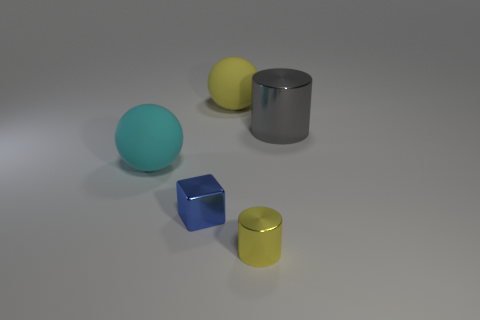The thing that is on the left side of the big yellow object and behind the cube is made of what material?
Your answer should be compact. Rubber. There is a big metallic thing behind the yellow metal cylinder; what is its shape?
Your response must be concise. Cylinder. What shape is the tiny metallic thing on the left side of the rubber sphere that is behind the gray cylinder?
Your response must be concise. Cube. Is there a large yellow object of the same shape as the small yellow object?
Offer a terse response. No. There is a metallic object that is the same size as the yellow shiny cylinder; what shape is it?
Offer a terse response. Cube. There is a shiny cylinder in front of the large rubber sphere that is on the left side of the large yellow matte ball; is there a yellow object on the left side of it?
Provide a succinct answer. Yes. Is there a blue object of the same size as the blue metal cube?
Offer a terse response. No. How big is the cylinder behind the small blue cube?
Give a very brief answer. Large. What is the color of the large sphere behind the gray object that is behind the tiny thing that is on the left side of the small yellow metal object?
Offer a terse response. Yellow. There is a cylinder that is in front of the big object that is on the left side of the yellow ball; what color is it?
Offer a very short reply. Yellow. 